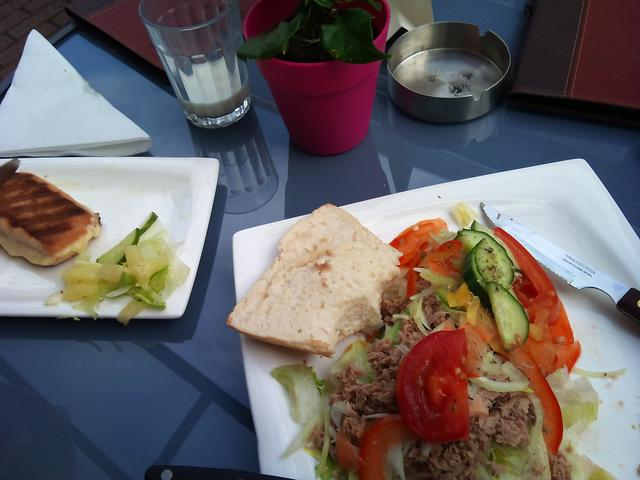What do the stains on the middle top metal thing come from? Please explain your reasoning. cigarettes. There are black ash spots on the metal item. 